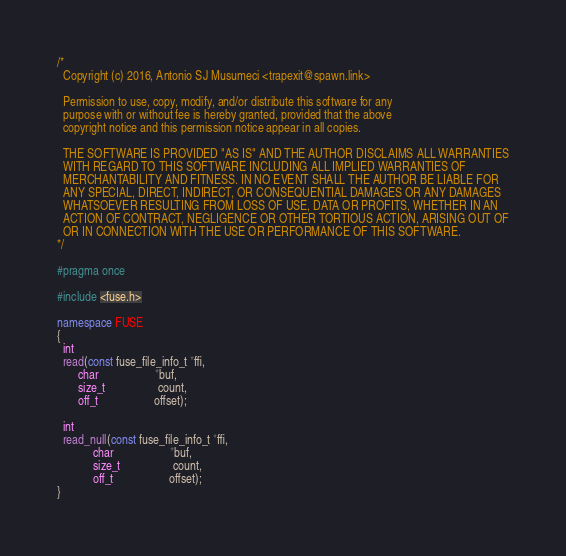<code> <loc_0><loc_0><loc_500><loc_500><_C++_>/*
  Copyright (c) 2016, Antonio SJ Musumeci <trapexit@spawn.link>

  Permission to use, copy, modify, and/or distribute this software for any
  purpose with or without fee is hereby granted, provided that the above
  copyright notice and this permission notice appear in all copies.

  THE SOFTWARE IS PROVIDED "AS IS" AND THE AUTHOR DISCLAIMS ALL WARRANTIES
  WITH REGARD TO THIS SOFTWARE INCLUDING ALL IMPLIED WARRANTIES OF
  MERCHANTABILITY AND FITNESS. IN NO EVENT SHALL THE AUTHOR BE LIABLE FOR
  ANY SPECIAL, DIRECT, INDIRECT, OR CONSEQUENTIAL DAMAGES OR ANY DAMAGES
  WHATSOEVER RESULTING FROM LOSS OF USE, DATA OR PROFITS, WHETHER IN AN
  ACTION OF CONTRACT, NEGLIGENCE OR OTHER TORTIOUS ACTION, ARISING OUT OF
  OR IN CONNECTION WITH THE USE OR PERFORMANCE OF THIS SOFTWARE.
*/

#pragma once

#include <fuse.h>

namespace FUSE
{
  int
  read(const fuse_file_info_t *ffi,
       char                   *buf,
       size_t                  count,
       off_t                   offset);

  int
  read_null(const fuse_file_info_t *ffi,
            char                   *buf,
            size_t                  count,
            off_t                   offset);
}
</code> 